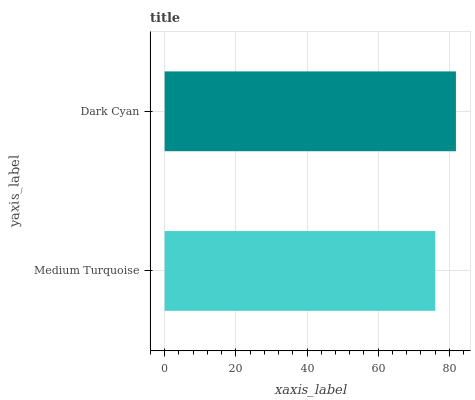Is Medium Turquoise the minimum?
Answer yes or no. Yes. Is Dark Cyan the maximum?
Answer yes or no. Yes. Is Dark Cyan the minimum?
Answer yes or no. No. Is Dark Cyan greater than Medium Turquoise?
Answer yes or no. Yes. Is Medium Turquoise less than Dark Cyan?
Answer yes or no. Yes. Is Medium Turquoise greater than Dark Cyan?
Answer yes or no. No. Is Dark Cyan less than Medium Turquoise?
Answer yes or no. No. Is Dark Cyan the high median?
Answer yes or no. Yes. Is Medium Turquoise the low median?
Answer yes or no. Yes. Is Medium Turquoise the high median?
Answer yes or no. No. Is Dark Cyan the low median?
Answer yes or no. No. 